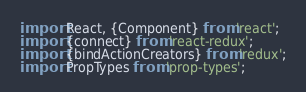<code> <loc_0><loc_0><loc_500><loc_500><_JavaScript_>import React, {Component} from 'react';
import {connect} from 'react-redux';
import {bindActionCreators} from 'redux';
import PropTypes from 'prop-types';</code> 